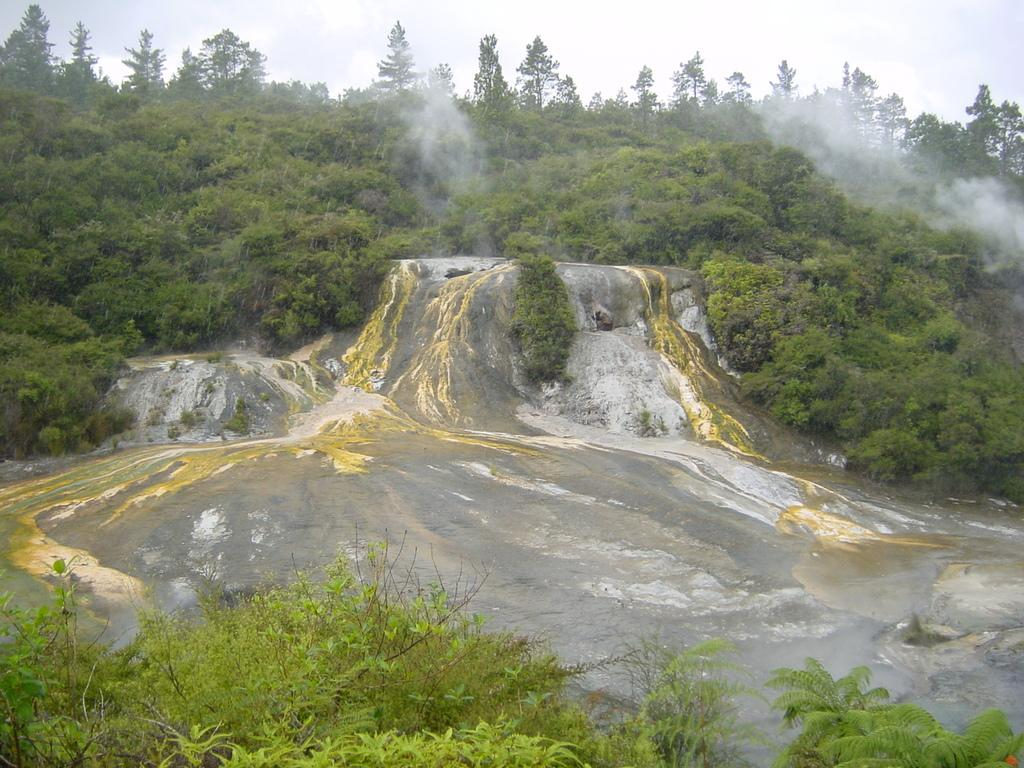What is the main object in the image? There is a rock in the image. What is present alongside the rock? There is water in the image. What can be seen in the background of the image? There are trees in the background of the image. What is the color of the trees? The trees are green. What is the color of the sky in the image? The sky is white in color. What type of pan is being used to cook the rock in the image? There is no pan or cooking activity present in the image; it features a rock and water with green trees in the background and a white sky. 